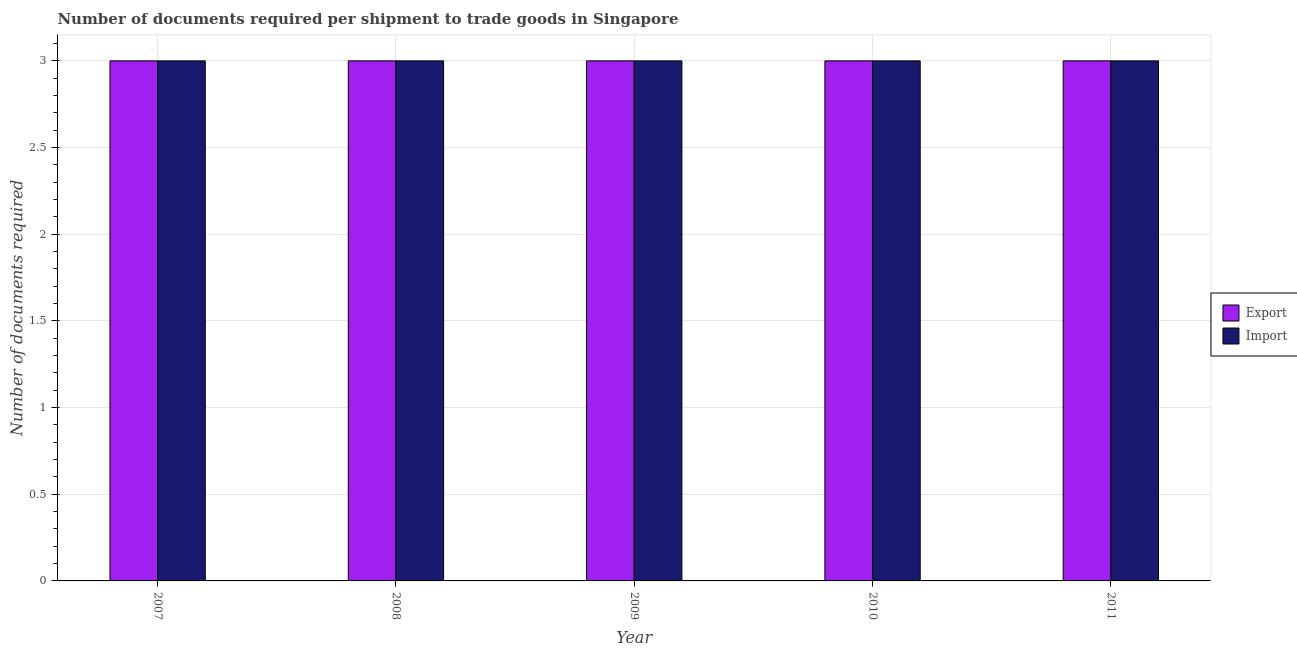How many different coloured bars are there?
Your response must be concise. 2. How many groups of bars are there?
Make the answer very short. 5. Are the number of bars per tick equal to the number of legend labels?
Make the answer very short. Yes. What is the label of the 2nd group of bars from the left?
Your answer should be very brief. 2008. In how many cases, is the number of bars for a given year not equal to the number of legend labels?
Your response must be concise. 0. What is the number of documents required to import goods in 2009?
Give a very brief answer. 3. Across all years, what is the maximum number of documents required to export goods?
Your answer should be very brief. 3. Across all years, what is the minimum number of documents required to import goods?
Provide a short and direct response. 3. In which year was the number of documents required to import goods minimum?
Keep it short and to the point. 2007. What is the total number of documents required to export goods in the graph?
Ensure brevity in your answer.  15. What is the average number of documents required to export goods per year?
Provide a short and direct response. 3. In the year 2007, what is the difference between the number of documents required to import goods and number of documents required to export goods?
Offer a terse response. 0. What does the 1st bar from the left in 2007 represents?
Keep it short and to the point. Export. What does the 1st bar from the right in 2008 represents?
Ensure brevity in your answer.  Import. How many bars are there?
Ensure brevity in your answer.  10. Are all the bars in the graph horizontal?
Your response must be concise. No. Does the graph contain any zero values?
Provide a short and direct response. No. Does the graph contain grids?
Your response must be concise. Yes. How many legend labels are there?
Make the answer very short. 2. How are the legend labels stacked?
Offer a very short reply. Vertical. What is the title of the graph?
Offer a very short reply. Number of documents required per shipment to trade goods in Singapore. What is the label or title of the X-axis?
Keep it short and to the point. Year. What is the label or title of the Y-axis?
Your answer should be very brief. Number of documents required. What is the Number of documents required in Export in 2007?
Your answer should be very brief. 3. What is the Number of documents required of Import in 2007?
Provide a short and direct response. 3. What is the Number of documents required in Export in 2008?
Make the answer very short. 3. What is the Number of documents required of Import in 2008?
Keep it short and to the point. 3. What is the Number of documents required of Import in 2009?
Your response must be concise. 3. What is the Number of documents required of Export in 2010?
Provide a short and direct response. 3. What is the Number of documents required in Import in 2011?
Provide a short and direct response. 3. Across all years, what is the minimum Number of documents required in Import?
Keep it short and to the point. 3. What is the total Number of documents required of Export in the graph?
Make the answer very short. 15. What is the total Number of documents required in Import in the graph?
Provide a succinct answer. 15. What is the difference between the Number of documents required of Export in 2007 and that in 2011?
Provide a succinct answer. 0. What is the difference between the Number of documents required of Import in 2008 and that in 2009?
Give a very brief answer. 0. What is the difference between the Number of documents required in Export in 2008 and that in 2011?
Give a very brief answer. 0. What is the difference between the Number of documents required in Import in 2008 and that in 2011?
Offer a terse response. 0. What is the difference between the Number of documents required of Export in 2009 and that in 2010?
Ensure brevity in your answer.  0. What is the difference between the Number of documents required in Import in 2009 and that in 2010?
Ensure brevity in your answer.  0. What is the difference between the Number of documents required of Export in 2009 and that in 2011?
Your response must be concise. 0. What is the difference between the Number of documents required in Export in 2007 and the Number of documents required in Import in 2009?
Ensure brevity in your answer.  0. What is the difference between the Number of documents required in Export in 2007 and the Number of documents required in Import in 2010?
Give a very brief answer. 0. What is the difference between the Number of documents required in Export in 2008 and the Number of documents required in Import in 2009?
Ensure brevity in your answer.  0. What is the difference between the Number of documents required in Export in 2008 and the Number of documents required in Import in 2010?
Your answer should be compact. 0. What is the difference between the Number of documents required in Export in 2009 and the Number of documents required in Import in 2011?
Your answer should be compact. 0. In the year 2007, what is the difference between the Number of documents required of Export and Number of documents required of Import?
Offer a very short reply. 0. In the year 2008, what is the difference between the Number of documents required of Export and Number of documents required of Import?
Make the answer very short. 0. In the year 2009, what is the difference between the Number of documents required in Export and Number of documents required in Import?
Your answer should be very brief. 0. In the year 2010, what is the difference between the Number of documents required in Export and Number of documents required in Import?
Provide a short and direct response. 0. What is the ratio of the Number of documents required of Export in 2007 to that in 2008?
Offer a very short reply. 1. What is the ratio of the Number of documents required of Import in 2007 to that in 2009?
Provide a succinct answer. 1. What is the ratio of the Number of documents required in Export in 2007 to that in 2010?
Give a very brief answer. 1. What is the ratio of the Number of documents required in Import in 2007 to that in 2010?
Offer a very short reply. 1. What is the ratio of the Number of documents required of Import in 2008 to that in 2010?
Provide a succinct answer. 1. What is the ratio of the Number of documents required in Export in 2009 to that in 2010?
Your answer should be compact. 1. What is the ratio of the Number of documents required of Import in 2009 to that in 2010?
Your answer should be very brief. 1. What is the ratio of the Number of documents required in Export in 2009 to that in 2011?
Your answer should be compact. 1. What is the ratio of the Number of documents required in Import in 2009 to that in 2011?
Ensure brevity in your answer.  1. What is the difference between the highest and the lowest Number of documents required in Import?
Provide a succinct answer. 0. 